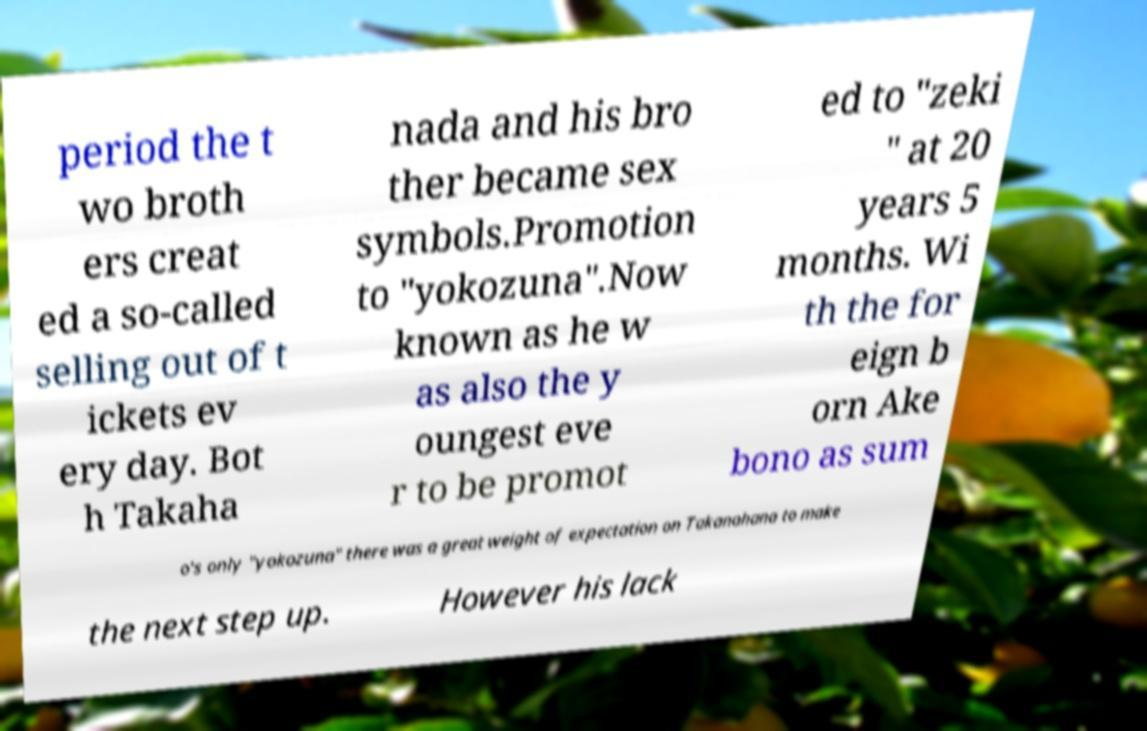Please read and relay the text visible in this image. What does it say? period the t wo broth ers creat ed a so-called selling out of t ickets ev ery day. Bot h Takaha nada and his bro ther became sex symbols.Promotion to "yokozuna".Now known as he w as also the y oungest eve r to be promot ed to "zeki " at 20 years 5 months. Wi th the for eign b orn Ake bono as sum o's only "yokozuna" there was a great weight of expectation on Takanohana to make the next step up. However his lack 